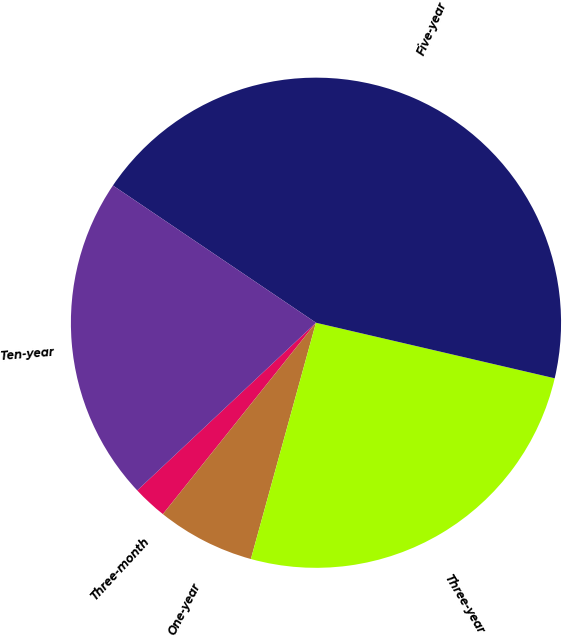Convert chart. <chart><loc_0><loc_0><loc_500><loc_500><pie_chart><fcel>Three-month<fcel>One-year<fcel>Three-year<fcel>Five-year<fcel>Ten-year<nl><fcel>2.27%<fcel>6.46%<fcel>25.64%<fcel>44.18%<fcel>21.45%<nl></chart> 